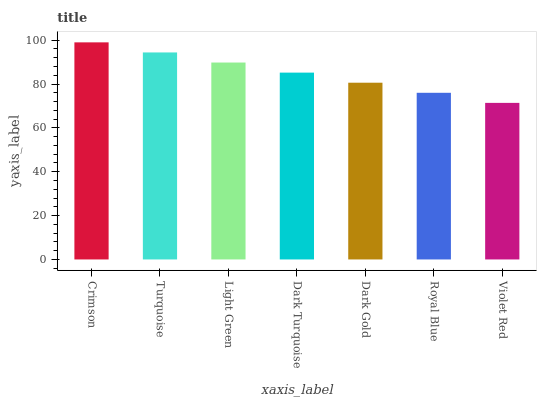Is Violet Red the minimum?
Answer yes or no. Yes. Is Crimson the maximum?
Answer yes or no. Yes. Is Turquoise the minimum?
Answer yes or no. No. Is Turquoise the maximum?
Answer yes or no. No. Is Crimson greater than Turquoise?
Answer yes or no. Yes. Is Turquoise less than Crimson?
Answer yes or no. Yes. Is Turquoise greater than Crimson?
Answer yes or no. No. Is Crimson less than Turquoise?
Answer yes or no. No. Is Dark Turquoise the high median?
Answer yes or no. Yes. Is Dark Turquoise the low median?
Answer yes or no. Yes. Is Dark Gold the high median?
Answer yes or no. No. Is Dark Gold the low median?
Answer yes or no. No. 